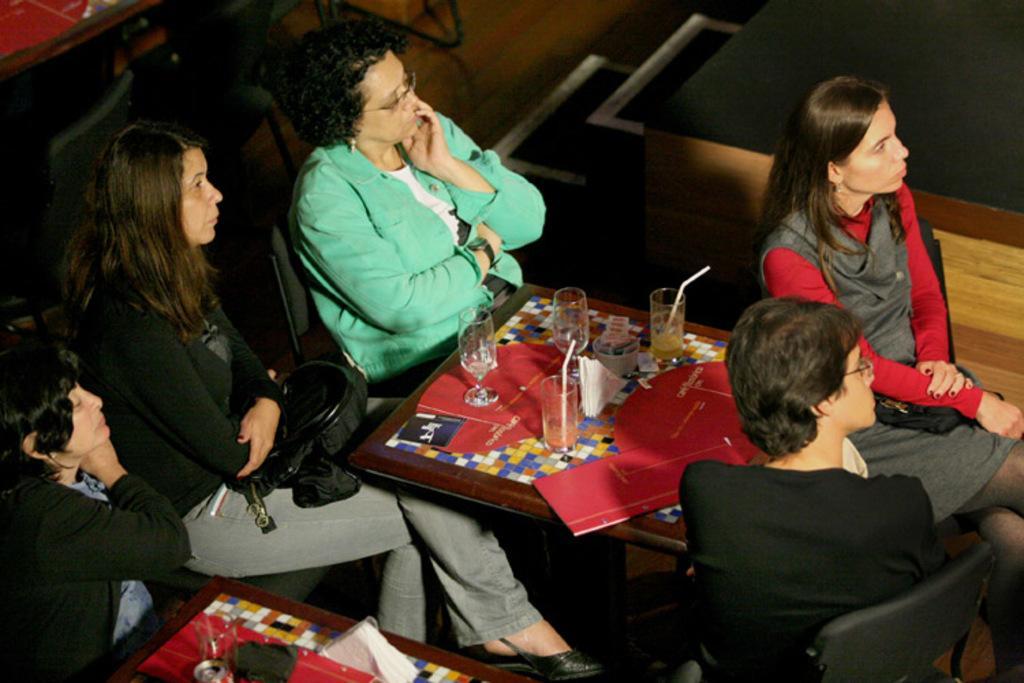How would you summarize this image in a sentence or two? There are a group of women sitting on a chairs around the table watching at something. There are few glasses placed on table. 